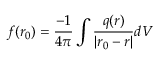<formula> <loc_0><loc_0><loc_500><loc_500>f ( r _ { 0 } ) = \frac { - 1 } { 4 \pi } \int \frac { q ( r ) } { | r _ { 0 } - r | } d V</formula> 